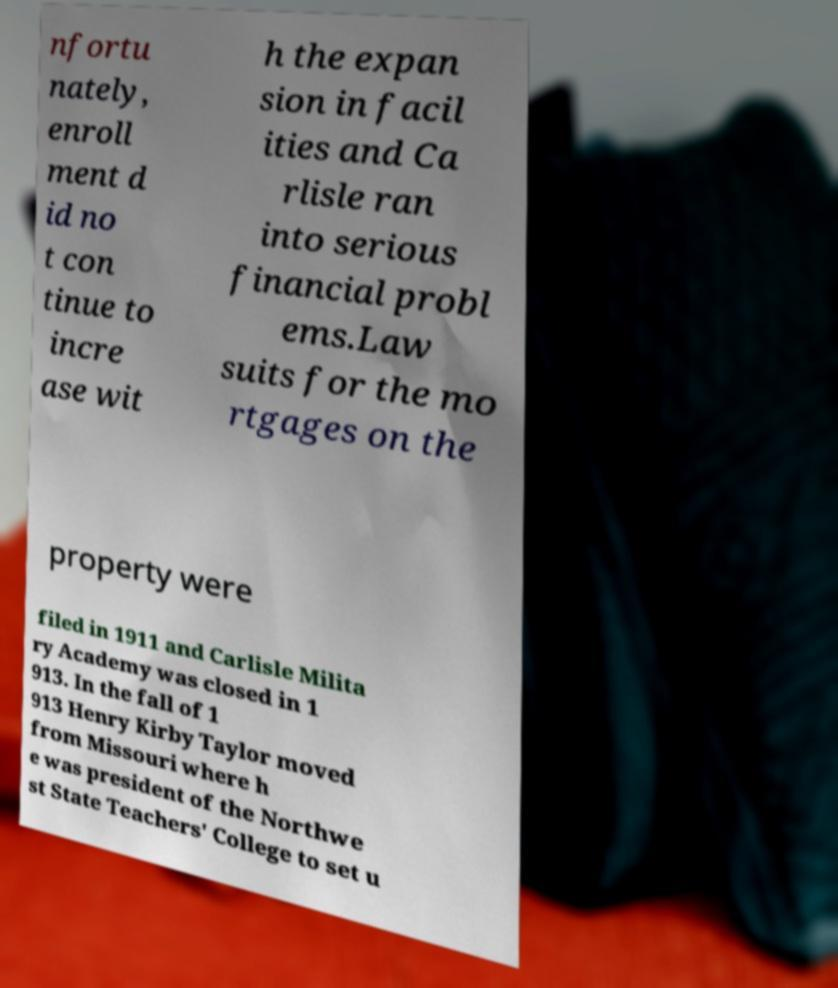Please identify and transcribe the text found in this image. nfortu nately, enroll ment d id no t con tinue to incre ase wit h the expan sion in facil ities and Ca rlisle ran into serious financial probl ems.Law suits for the mo rtgages on the property were filed in 1911 and Carlisle Milita ry Academy was closed in 1 913. In the fall of 1 913 Henry Kirby Taylor moved from Missouri where h e was president of the Northwe st State Teachers' College to set u 